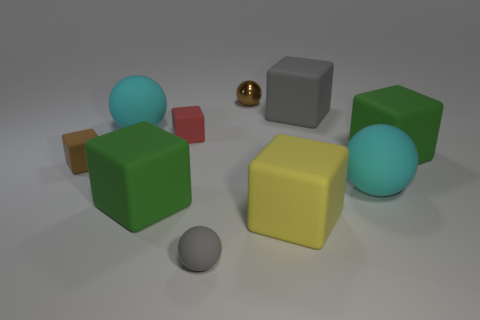Subtract all red blocks. How many blocks are left? 5 Subtract all tiny blocks. How many blocks are left? 4 Subtract all cyan blocks. Subtract all purple balls. How many blocks are left? 6 Subtract all cubes. How many objects are left? 4 Add 5 big gray matte things. How many big gray matte things are left? 6 Add 2 small brown matte spheres. How many small brown matte spheres exist? 2 Subtract 0 red spheres. How many objects are left? 10 Subtract all small spheres. Subtract all matte blocks. How many objects are left? 2 